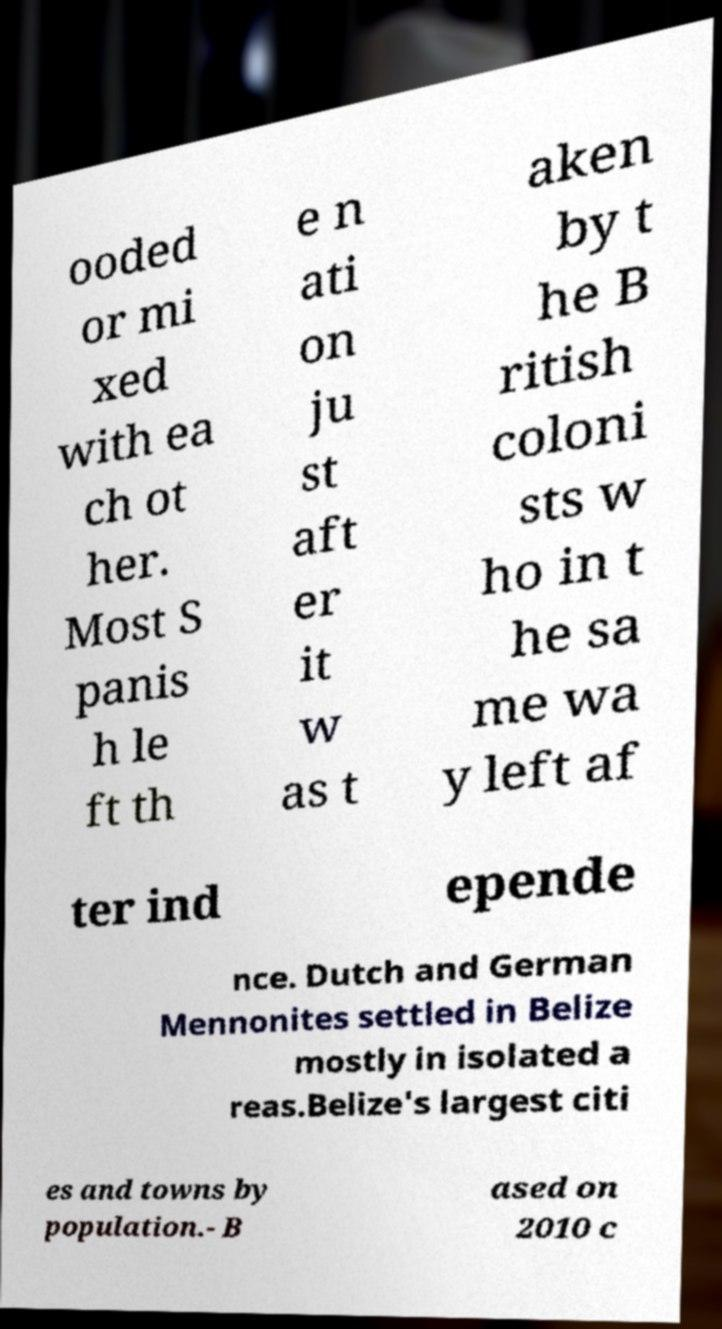Please read and relay the text visible in this image. What does it say? ooded or mi xed with ea ch ot her. Most S panis h le ft th e n ati on ju st aft er it w as t aken by t he B ritish coloni sts w ho in t he sa me wa y left af ter ind epende nce. Dutch and German Mennonites settled in Belize mostly in isolated a reas.Belize's largest citi es and towns by population.- B ased on 2010 c 